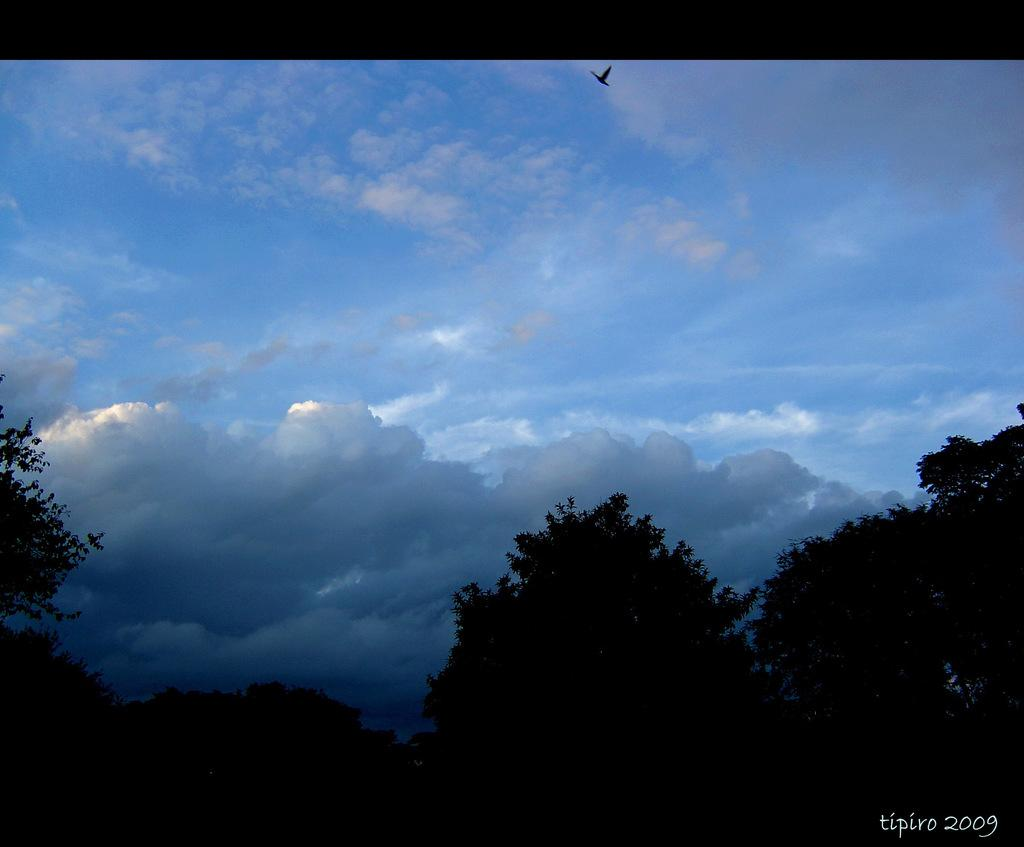What is the primary feature of the image? There are many trees in the image. What can be seen in the background of the image? The sky with clouds is visible in the background of the image. Is there any additional information or marking in the image? Yes, there is a watermark in the right corner of the image. Can you hear the whistle of the birds in the trees in the image? There is no sound in the image, and no birds are mentioned, so it is not possible to hear any whistling. 